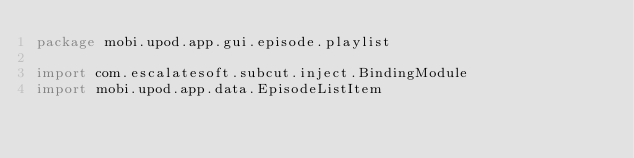<code> <loc_0><loc_0><loc_500><loc_500><_Scala_>package mobi.upod.app.gui.episode.playlist

import com.escalatesoft.subcut.inject.BindingModule
import mobi.upod.app.data.EpisodeListItem
</code> 